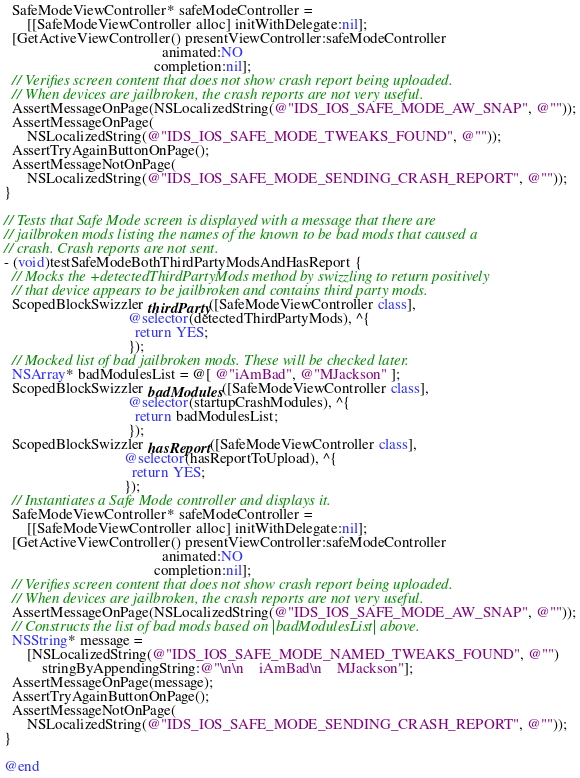<code> <loc_0><loc_0><loc_500><loc_500><_ObjectiveC_>  SafeModeViewController* safeModeController =
      [[SafeModeViewController alloc] initWithDelegate:nil];
  [GetActiveViewController() presentViewController:safeModeController
                                          animated:NO
                                        completion:nil];
  // Verifies screen content that does not show crash report being uploaded.
  // When devices are jailbroken, the crash reports are not very useful.
  AssertMessageOnPage(NSLocalizedString(@"IDS_IOS_SAFE_MODE_AW_SNAP", @""));
  AssertMessageOnPage(
      NSLocalizedString(@"IDS_IOS_SAFE_MODE_TWEAKS_FOUND", @""));
  AssertTryAgainButtonOnPage();
  AssertMessageNotOnPage(
      NSLocalizedString(@"IDS_IOS_SAFE_MODE_SENDING_CRASH_REPORT", @""));
}

// Tests that Safe Mode screen is displayed with a message that there are
// jailbroken mods listing the names of the known to be bad mods that caused a
// crash. Crash reports are not sent.
- (void)testSafeModeBothThirdPartyModsAndHasReport {
  // Mocks the +detectedThirdPartyMods method by swizzling to return positively
  // that device appears to be jailbroken and contains third party mods.
  ScopedBlockSwizzler thirdParty([SafeModeViewController class],
                                 @selector(detectedThirdPartyMods), ^{
                                   return YES;
                                 });
  // Mocked list of bad jailbroken mods. These will be checked later.
  NSArray* badModulesList = @[ @"iAmBad", @"MJackson" ];
  ScopedBlockSwizzler badModules([SafeModeViewController class],
                                 @selector(startupCrashModules), ^{
                                   return badModulesList;
                                 });
  ScopedBlockSwizzler hasReport([SafeModeViewController class],
                                @selector(hasReportToUpload), ^{
                                  return YES;
                                });
  // Instantiates a Safe Mode controller and displays it.
  SafeModeViewController* safeModeController =
      [[SafeModeViewController alloc] initWithDelegate:nil];
  [GetActiveViewController() presentViewController:safeModeController
                                          animated:NO
                                        completion:nil];
  // Verifies screen content that does not show crash report being uploaded.
  // When devices are jailbroken, the crash reports are not very useful.
  AssertMessageOnPage(NSLocalizedString(@"IDS_IOS_SAFE_MODE_AW_SNAP", @""));
  // Constructs the list of bad mods based on |badModulesList| above.
  NSString* message =
      [NSLocalizedString(@"IDS_IOS_SAFE_MODE_NAMED_TWEAKS_FOUND", @"")
          stringByAppendingString:@"\n\n    iAmBad\n    MJackson"];
  AssertMessageOnPage(message);
  AssertTryAgainButtonOnPage();
  AssertMessageNotOnPage(
      NSLocalizedString(@"IDS_IOS_SAFE_MODE_SENDING_CRASH_REPORT", @""));
}

@end
</code> 